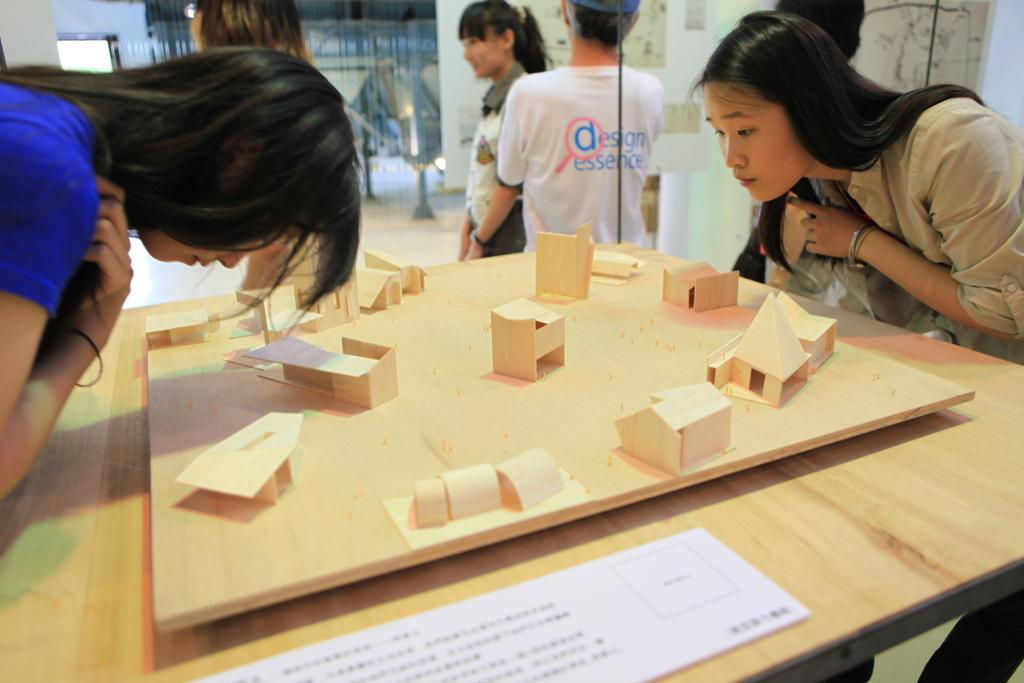What is the general activity of the people in the image? There is a group of people standing in the image. How many women are in the group? There are two women in the group. What is in front of the two women? There is a table in front of the two women. What can be seen on the table? There is a wood craft on the table. What type of ice can be seen melting on the back of the wood craft in the image? There is no ice present in the image, and the wood craft does not have a back. 